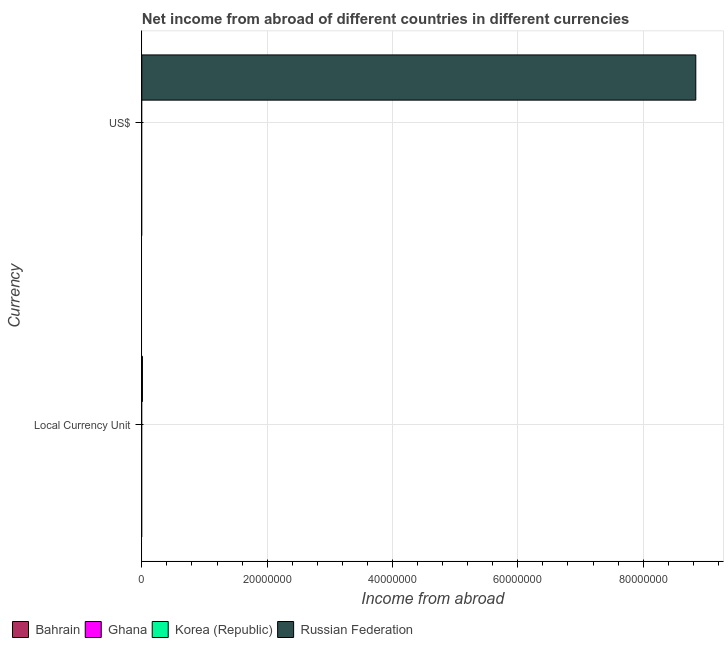How many different coloured bars are there?
Your answer should be very brief. 1. Are the number of bars per tick equal to the number of legend labels?
Give a very brief answer. No. Are the number of bars on each tick of the Y-axis equal?
Keep it short and to the point. Yes. What is the label of the 2nd group of bars from the top?
Give a very brief answer. Local Currency Unit. Across all countries, what is the maximum income from abroad in constant 2005 us$?
Offer a very short reply. 1.00e+05. In which country was the income from abroad in constant 2005 us$ maximum?
Keep it short and to the point. Russian Federation. What is the difference between the income from abroad in us$ in Bahrain and the income from abroad in constant 2005 us$ in Korea (Republic)?
Provide a succinct answer. 0. What is the average income from abroad in constant 2005 us$ per country?
Your response must be concise. 2.50e+04. What is the difference between the income from abroad in us$ and income from abroad in constant 2005 us$ in Russian Federation?
Provide a short and direct response. 8.83e+07. How many bars are there?
Provide a succinct answer. 2. Are all the bars in the graph horizontal?
Make the answer very short. Yes. What is the difference between two consecutive major ticks on the X-axis?
Give a very brief answer. 2.00e+07. Are the values on the major ticks of X-axis written in scientific E-notation?
Your answer should be compact. No. Does the graph contain any zero values?
Provide a short and direct response. Yes. Does the graph contain grids?
Your response must be concise. Yes. How many legend labels are there?
Provide a succinct answer. 4. How are the legend labels stacked?
Your answer should be compact. Horizontal. What is the title of the graph?
Offer a very short reply. Net income from abroad of different countries in different currencies. Does "Sudan" appear as one of the legend labels in the graph?
Ensure brevity in your answer.  No. What is the label or title of the X-axis?
Ensure brevity in your answer.  Income from abroad. What is the label or title of the Y-axis?
Your answer should be compact. Currency. What is the Income from abroad of Bahrain in US$?
Offer a terse response. 0. What is the Income from abroad in Korea (Republic) in US$?
Give a very brief answer. 0. What is the Income from abroad in Russian Federation in US$?
Provide a short and direct response. 8.84e+07. Across all Currency, what is the maximum Income from abroad of Russian Federation?
Your response must be concise. 8.84e+07. Across all Currency, what is the minimum Income from abroad in Russian Federation?
Provide a succinct answer. 1.00e+05. What is the total Income from abroad in Ghana in the graph?
Offer a very short reply. 0. What is the total Income from abroad in Korea (Republic) in the graph?
Keep it short and to the point. 0. What is the total Income from abroad of Russian Federation in the graph?
Keep it short and to the point. 8.85e+07. What is the difference between the Income from abroad in Russian Federation in Local Currency Unit and that in US$?
Give a very brief answer. -8.83e+07. What is the average Income from abroad in Ghana per Currency?
Provide a short and direct response. 0. What is the average Income from abroad in Korea (Republic) per Currency?
Make the answer very short. 0. What is the average Income from abroad in Russian Federation per Currency?
Make the answer very short. 4.42e+07. What is the ratio of the Income from abroad in Russian Federation in Local Currency Unit to that in US$?
Give a very brief answer. 0. What is the difference between the highest and the second highest Income from abroad in Russian Federation?
Keep it short and to the point. 8.83e+07. What is the difference between the highest and the lowest Income from abroad in Russian Federation?
Make the answer very short. 8.83e+07. 